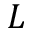Convert formula to latex. <formula><loc_0><loc_0><loc_500><loc_500>L</formula> 